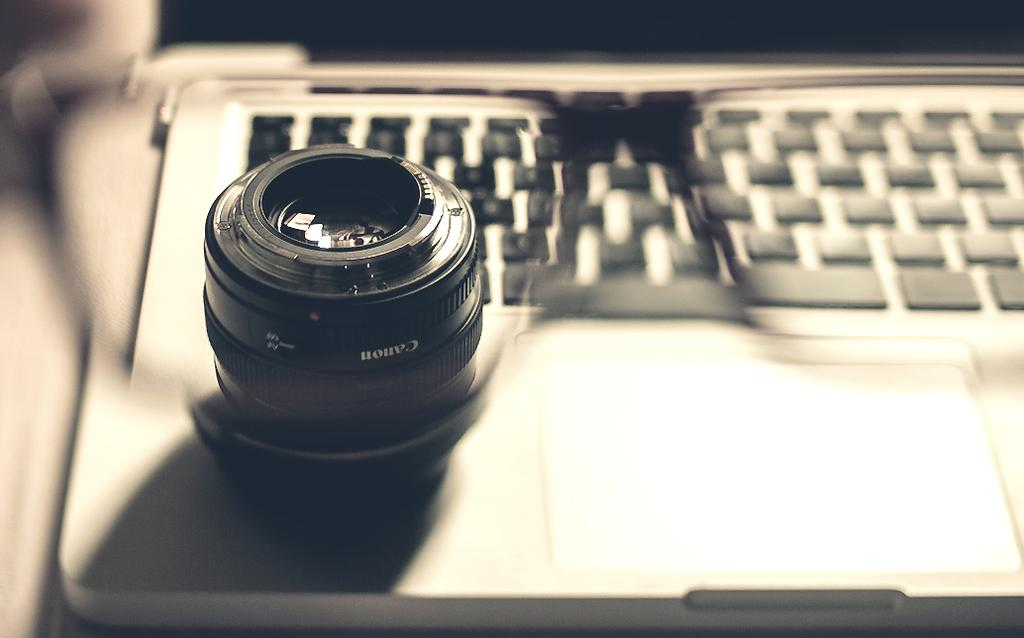What object is present in the image that people use to see more clearly? There are spectacles in the image. What can be seen through the spectacles in the image? A camera and a laptop are visible through the spectacles. What is the feeling of the basin in the image? There is no basin present in the image, so it is not possible to determine its feeling. 